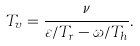Convert formula to latex. <formula><loc_0><loc_0><loc_500><loc_500>T _ { v } = \frac { \nu } { \varepsilon / T _ { r } - \omega / T _ { h } } .</formula> 